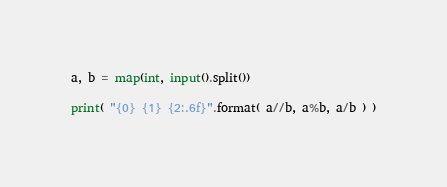Convert code to text. <code><loc_0><loc_0><loc_500><loc_500><_Python_>a, b = map(int, input().split())

print( "{0} {1} {2:.6f}".format( a//b, a%b, a/b ) )</code> 